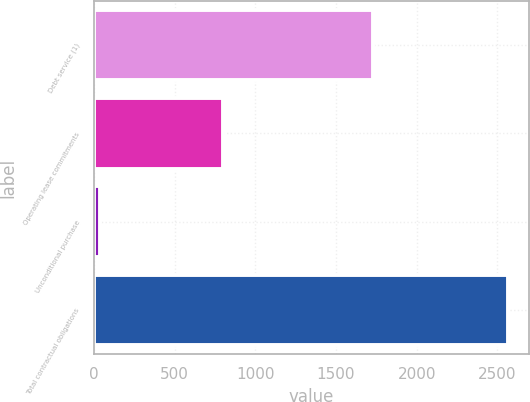Convert chart to OTSL. <chart><loc_0><loc_0><loc_500><loc_500><bar_chart><fcel>Debt service (1)<fcel>Operating lease commitments<fcel>Unconditional purchase<fcel>Total contractual obligations<nl><fcel>1728.8<fcel>797.9<fcel>39.2<fcel>2565.9<nl></chart> 